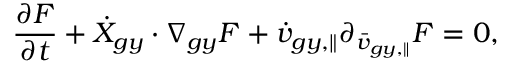<formula> <loc_0><loc_0><loc_500><loc_500>\frac { \partial F } { \partial t } + \dot { X } _ { g y } \cdot \nabla _ { g y } F + \dot { v } _ { g y , \| } \partial _ { \bar { v } _ { g y , \| } } F = 0 ,</formula> 